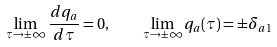<formula> <loc_0><loc_0><loc_500><loc_500>\lim _ { \tau \to \pm \infty } \frac { d q _ { a } } { d \tau } = 0 , \quad \lim _ { \tau \to \pm \infty } q _ { a } ( \tau ) = \pm \delta _ { a 1 }</formula> 